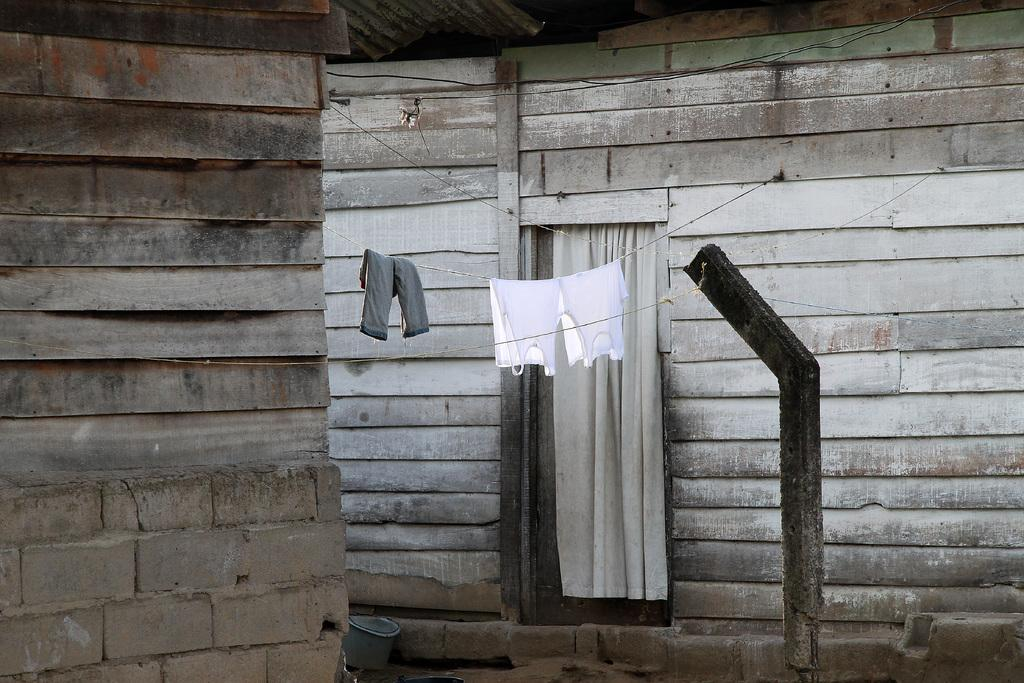What type of structure is visible in the image? There is a shed in the image. What can be seen hanging from the rope in the image? Clothes are hanging on a rope in the image. How many sheep are visible in the image? There are no sheep present in the image. What book is the person reading in the image? There is no person reading a book in the image. 